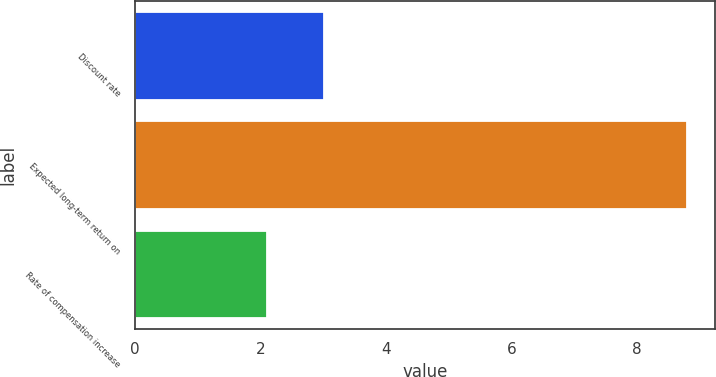<chart> <loc_0><loc_0><loc_500><loc_500><bar_chart><fcel>Discount rate<fcel>Expected long-term return on<fcel>Rate of compensation increase<nl><fcel>3<fcel>8.8<fcel>2.1<nl></chart> 